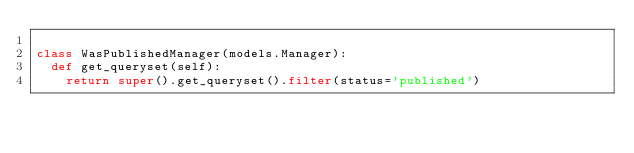<code> <loc_0><loc_0><loc_500><loc_500><_Python_>
class WasPublishedManager(models.Manager):
	def get_queryset(self):
		return super().get_queryset().filter(status='published')
		</code> 